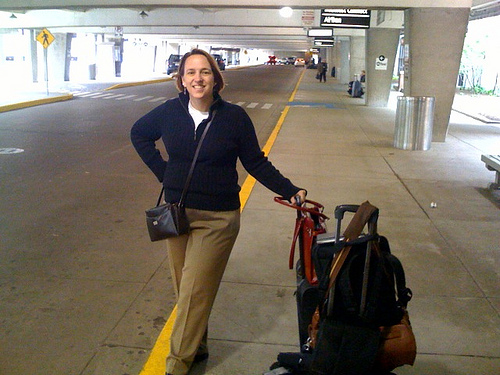What do you see happening in this image? In the image, there is a woman standing in what appears to be an airport or a bus terminal. She stands confidently with a smile, holding onto the handle of a suitcase that is accompanied by a couple more bags nearby. The environment suggests she might be about to embark on a journey or has just arrived. Surrounding her, we also notice two trash cans and a spacious area ahead with other individuals in the distance. 